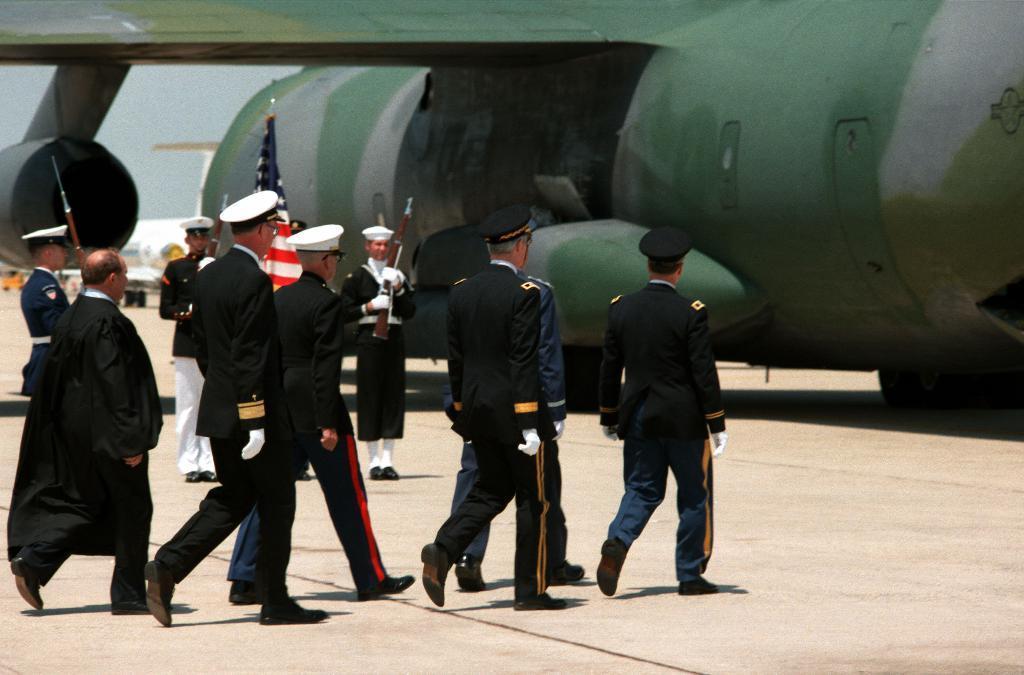Can you describe this image briefly? In this image I can see the group of people with black, navy blue and the white color dresses. In-front of these people I can see an aircraft which is in green color. In the background I can see one more aircraft and the sky. 